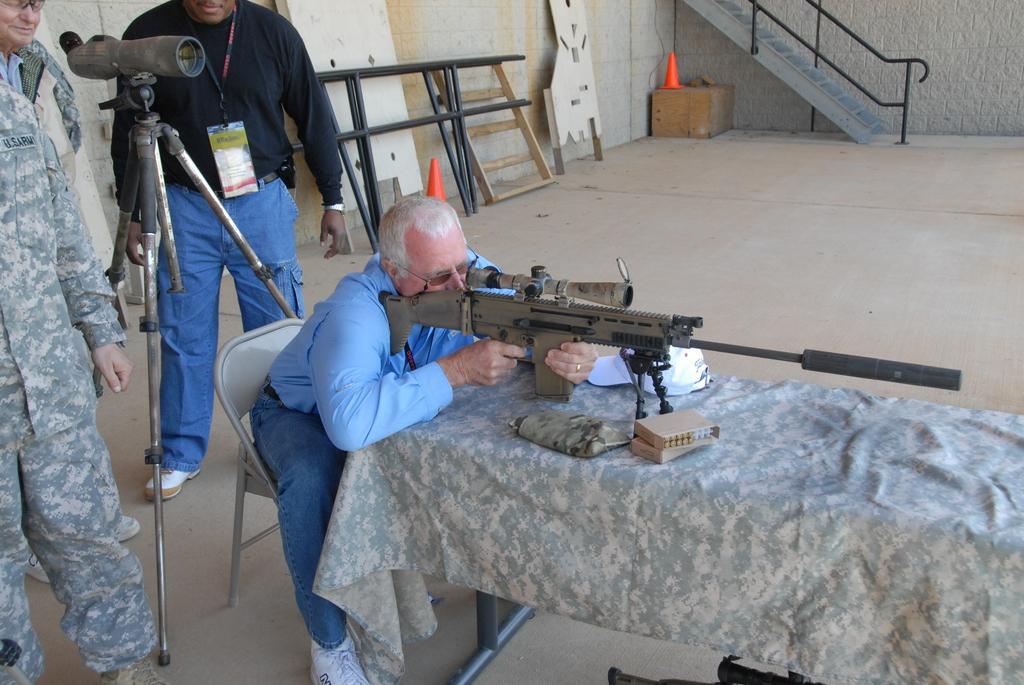Can you describe this image briefly? This image consists of stairs at the top. There is a table, on that there are bullets and gun. A person is holding that gun. There are some persons on the left side. 